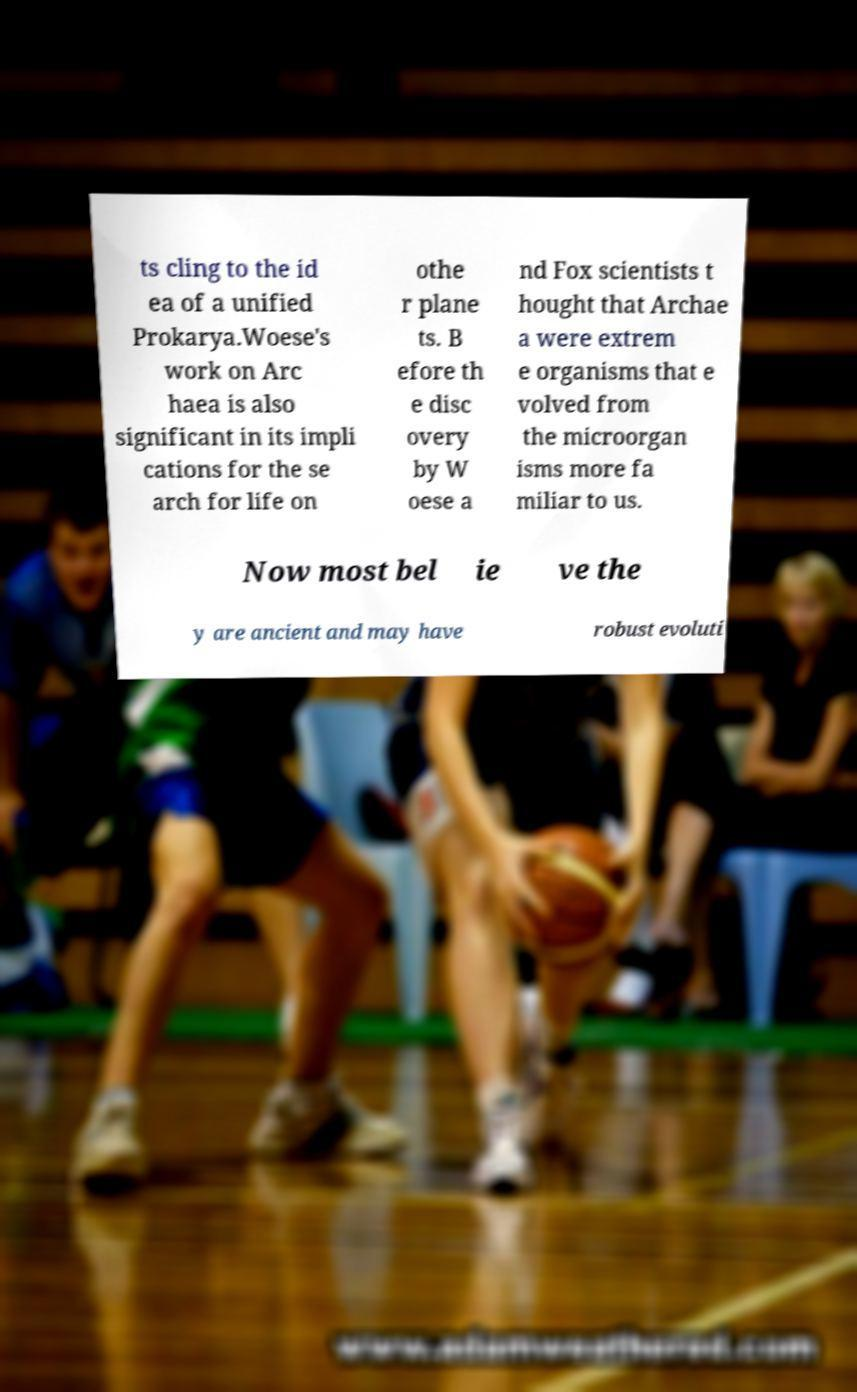Could you extract and type out the text from this image? ts cling to the id ea of a unified Prokarya.Woese's work on Arc haea is also significant in its impli cations for the se arch for life on othe r plane ts. B efore th e disc overy by W oese a nd Fox scientists t hought that Archae a were extrem e organisms that e volved from the microorgan isms more fa miliar to us. Now most bel ie ve the y are ancient and may have robust evoluti 